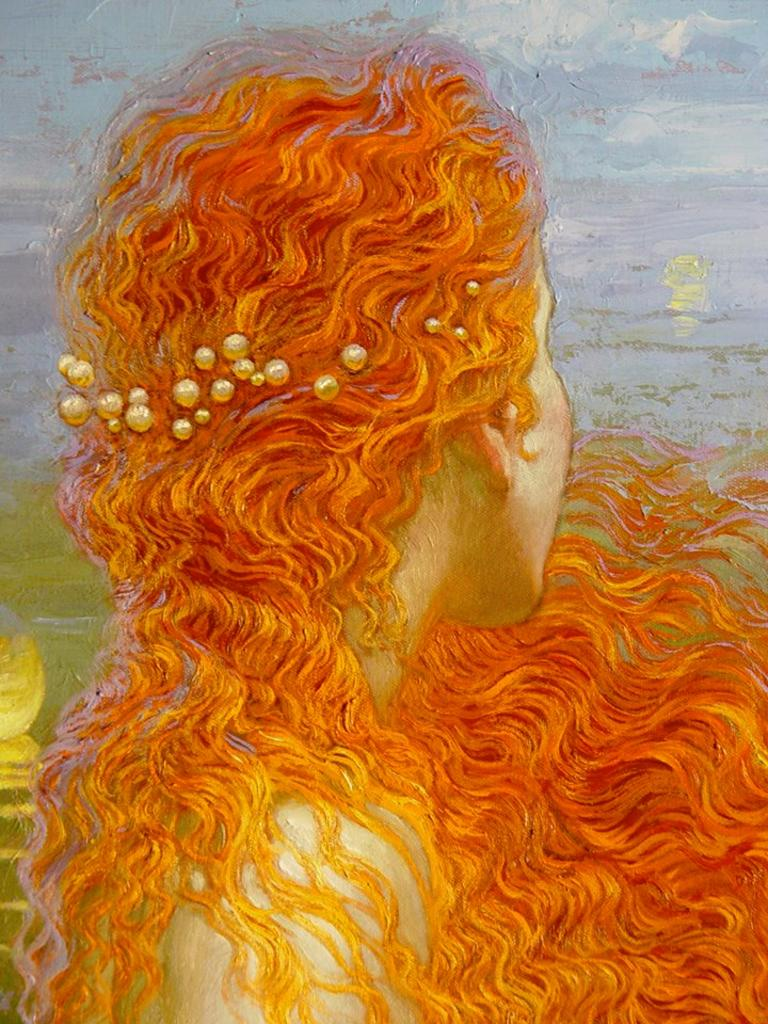What is the main subject of the image? There is a painting in the image. What does the painting depict? The painting depicts a girl. What type of book is the girl reading in the painting? There is no book present in the painting; it only depicts a girl. 